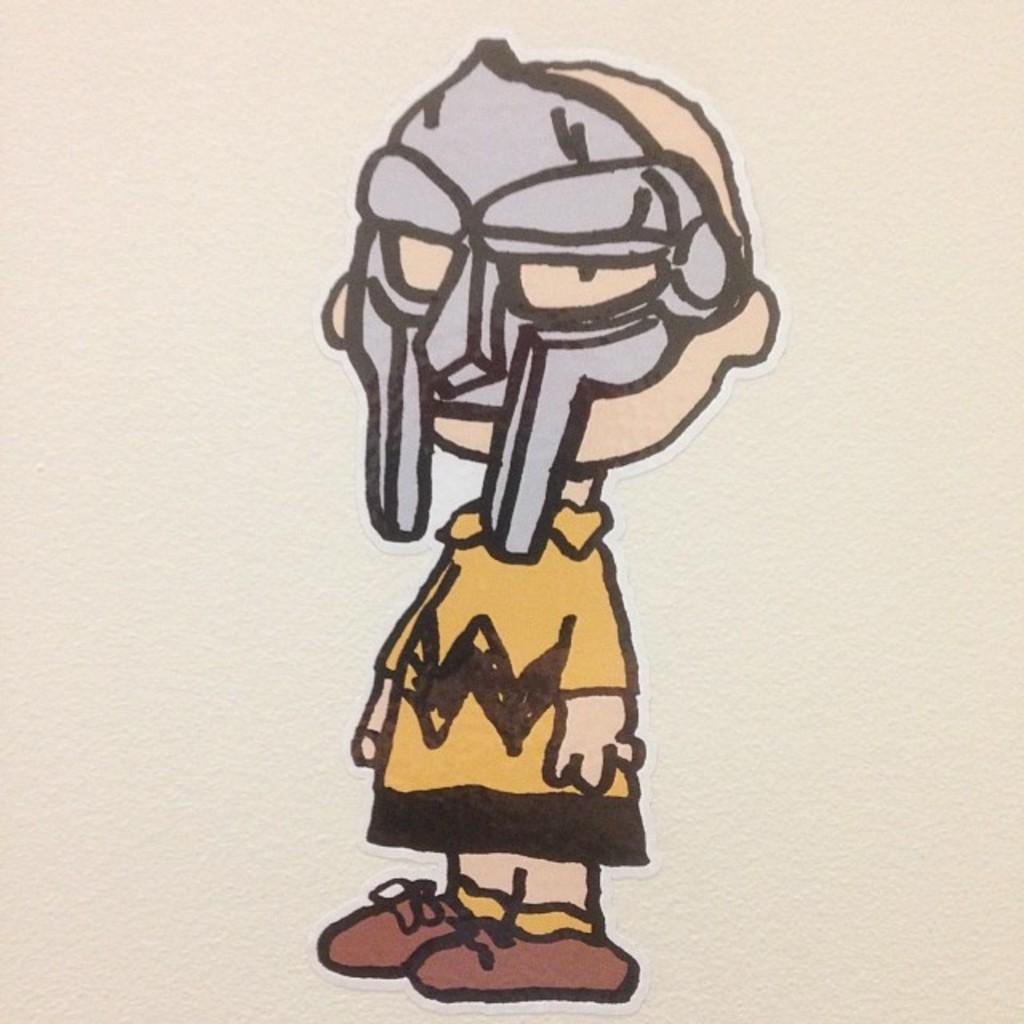Describe this image in one or two sentences. In this image, we can see a human sticker on the wall. Here we can see this person is wearing a mask. 